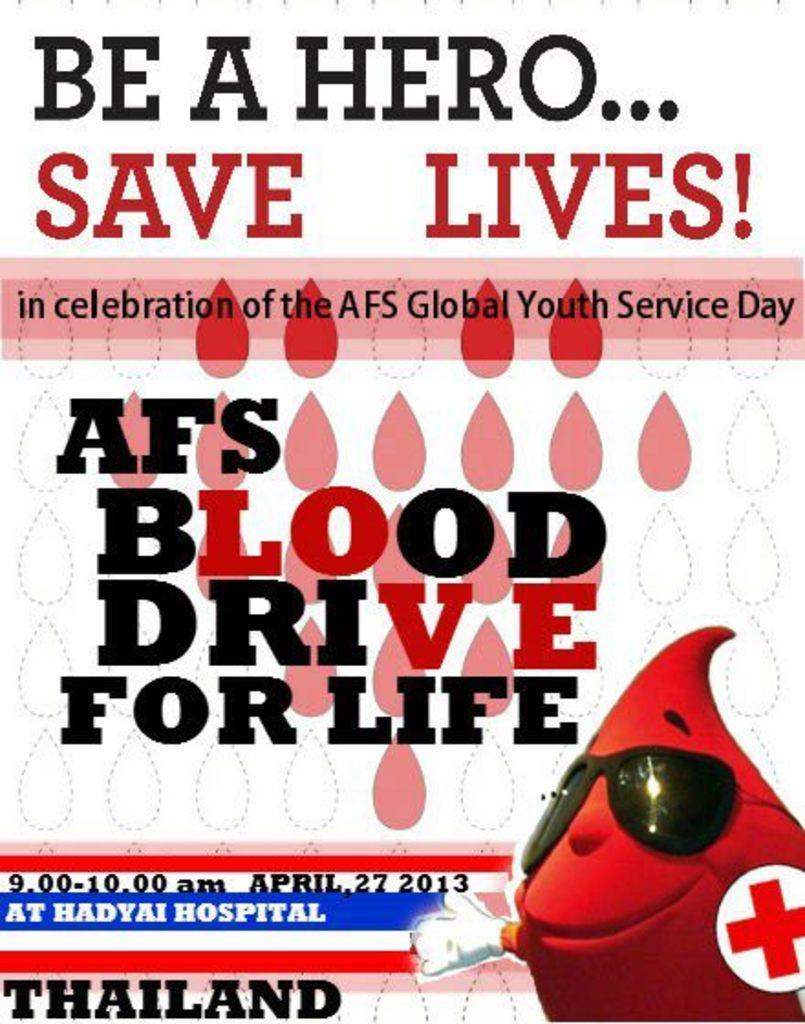In one or two sentences, can you explain what this image depicts? In this image we can see the poster with some text and in the bottom right side we can see a cartoon picture. 